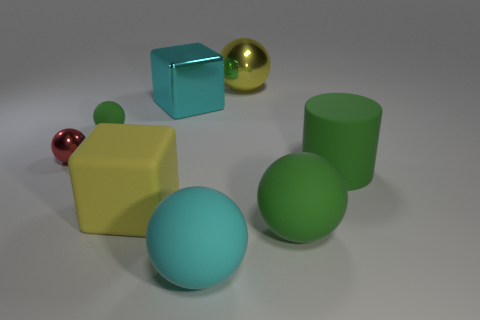Subtract all brown cylinders. How many green balls are left? 2 Subtract all tiny rubber balls. How many balls are left? 4 Subtract 3 balls. How many balls are left? 2 Subtract all green balls. How many balls are left? 3 Subtract all yellow spheres. Subtract all gray cylinders. How many spheres are left? 4 Add 1 blocks. How many objects exist? 9 Subtract all blocks. How many objects are left? 6 Add 1 small purple matte balls. How many small purple matte balls exist? 1 Subtract 1 cyan blocks. How many objects are left? 7 Subtract all big matte cylinders. Subtract all yellow things. How many objects are left? 5 